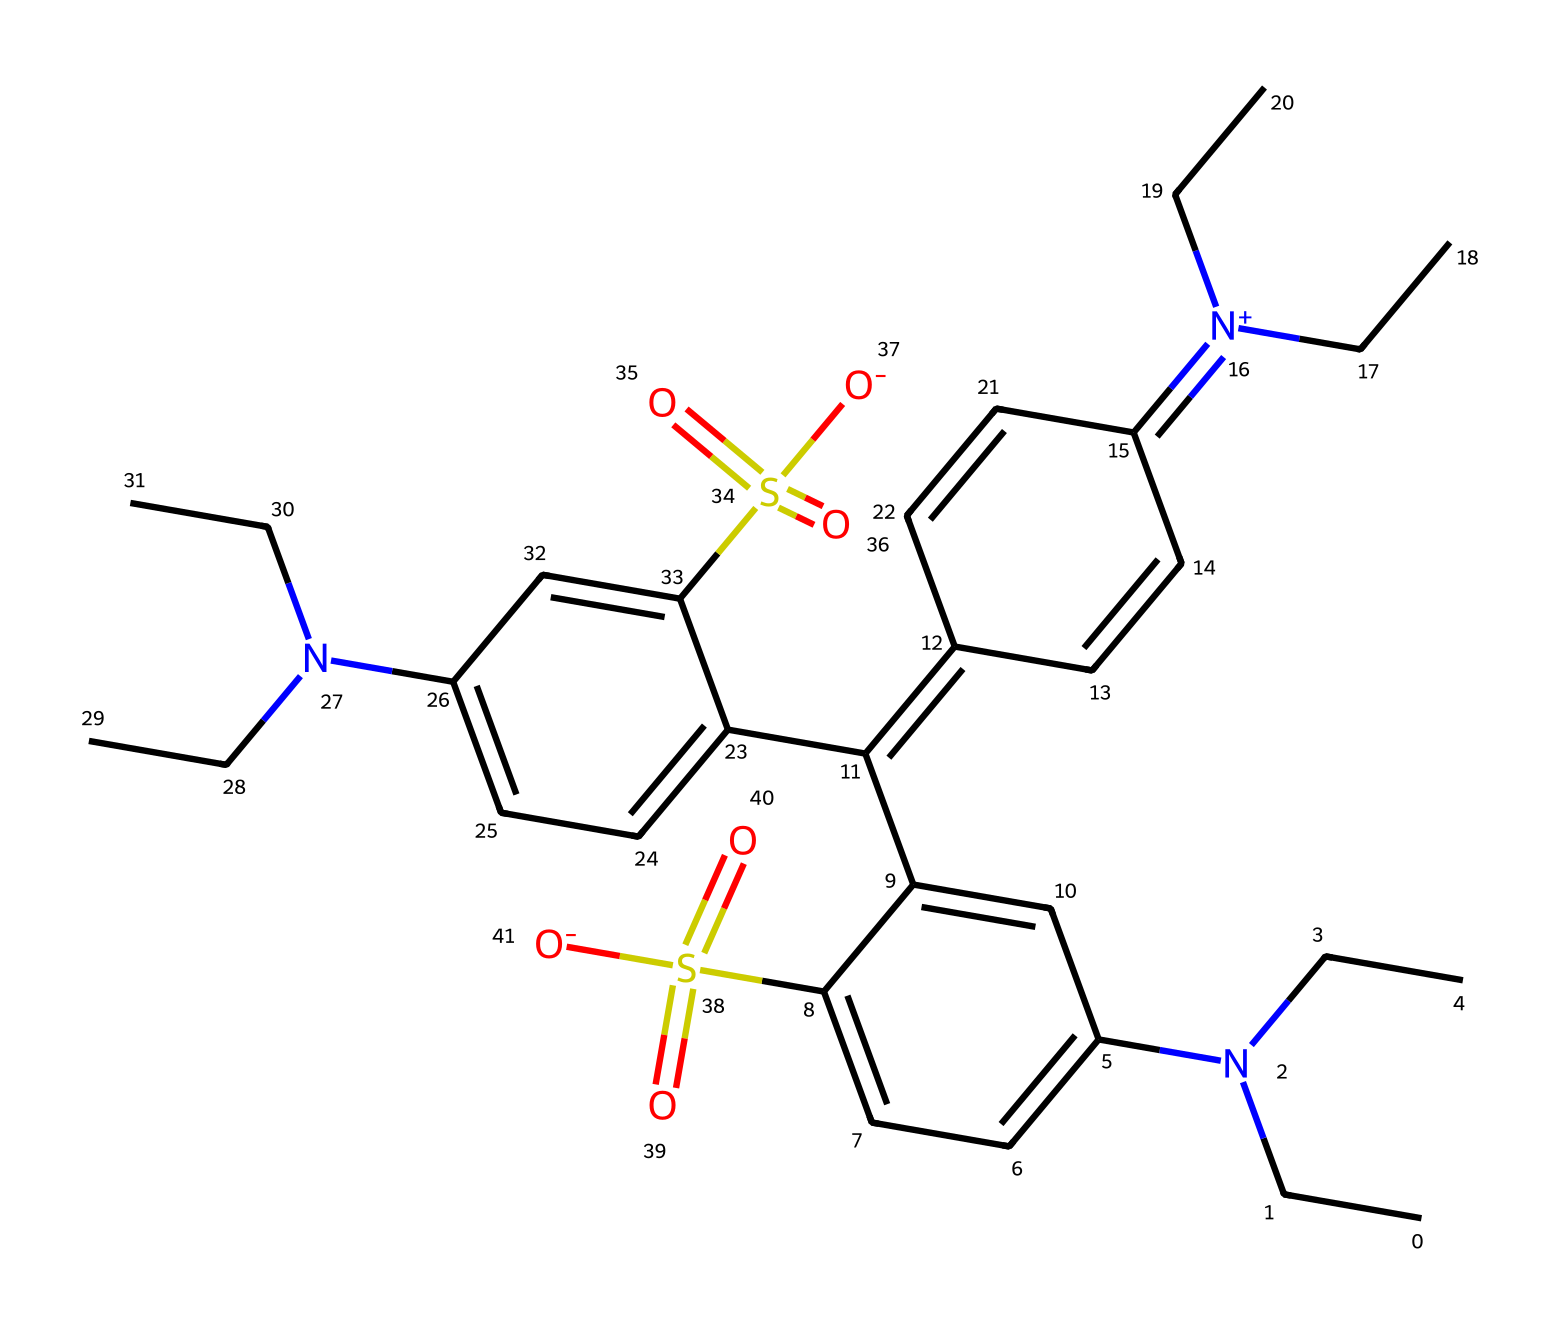What is the main functional group present in this chemical structure? The chemical contains sulfonyl groups, indicated by the presence of sulfur atom bonded to two oxygen atoms with double bonds (S(=O)(=O)). These are characteristic of sulfonic acids or sulfonamides.
Answer: sulfonyl How many nitrogen atoms are in this chemical? The SMILES representation shows three nitrogen atoms (N) present in the structure. They can be counted based on their individual representations in the SMILES.
Answer: three What type of chemical compound is this classified as? Given the presence of the sulfonyl group and the various amine groups (N) in the structure, this compound can be classified as a sulfonamide.
Answer: sulfonamide In which element does this chemical primarily derive its green color? The color green in food colorings often comes from the presence of specific chromophores such as azo or related structures; in this case, the nitrogen-stabilized double bonds appear to have an important role.
Answer: nitrogen What is the total number of carbon atoms present in this compound? By counting the number of carbon atoms (C) from the SMILES representation, we find there are a total of 25 carbon atoms represented in the chemical structure.
Answer: twenty-five Why might this compound be used in food coloring for St. Patrick's Day? The structure indicates a stable configuration with colors that are pleasing and safe for consumption. Moreover, the presence of functional groups, like the sulfonyl, helps enhance solubility, making it more suitable for food items.
Answer: stability 